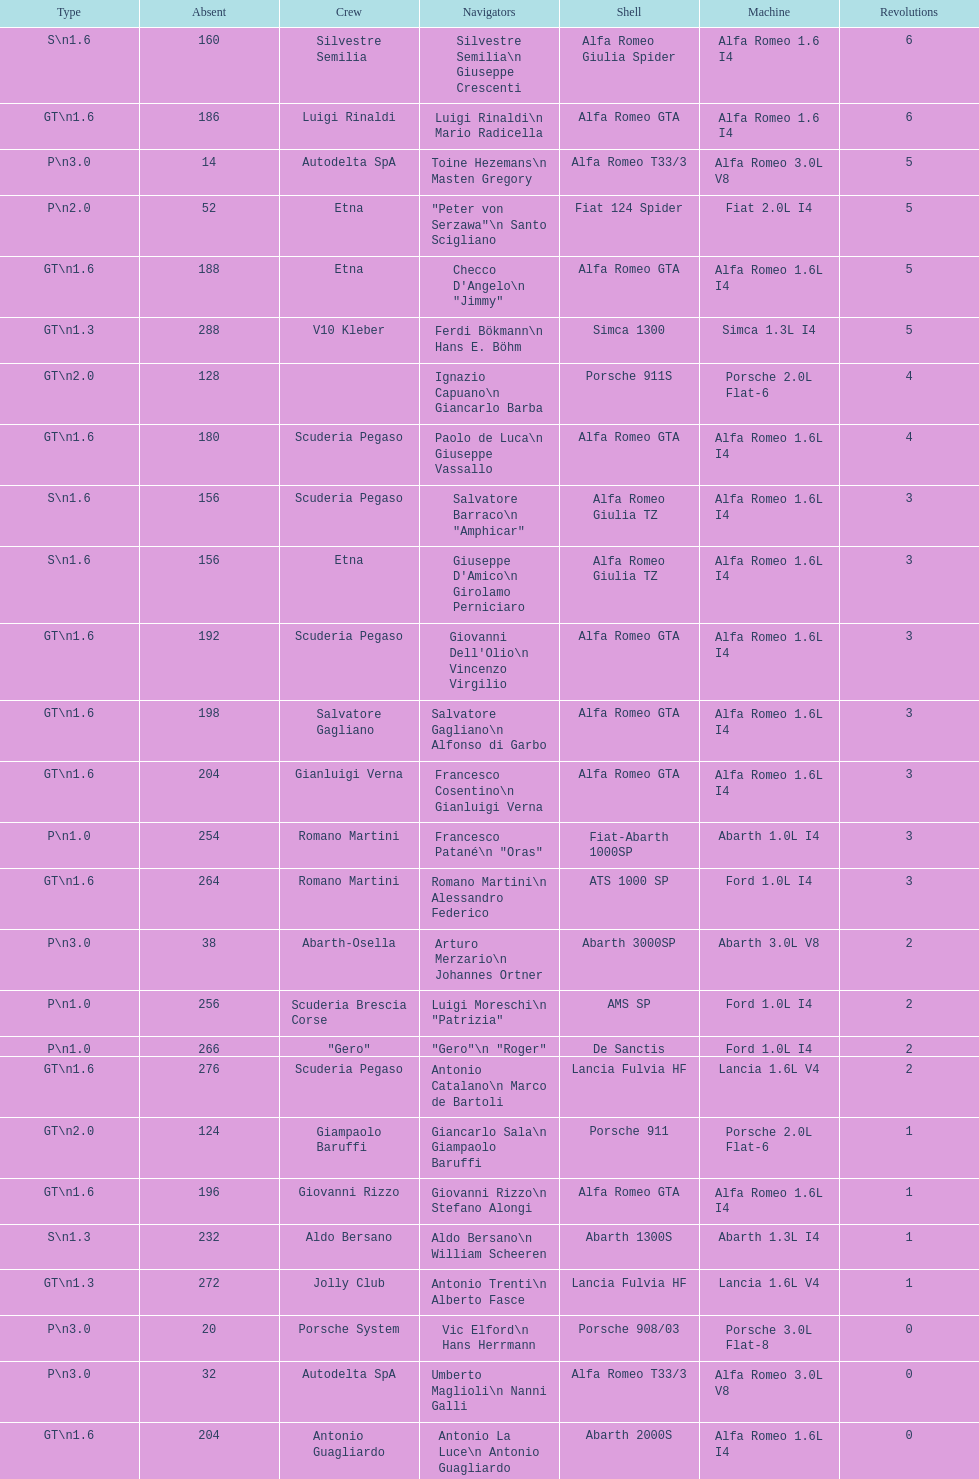How many teams were unable to finish the race following the completion of 2 laps? 4. Parse the table in full. {'header': ['Type', 'Absent', 'Crew', 'Navigators', 'Shell', 'Machine', 'Revolutions'], 'rows': [['S\\n1.6', '160', 'Silvestre Semilia', 'Silvestre Semilia\\n Giuseppe Crescenti', 'Alfa Romeo Giulia Spider', 'Alfa Romeo 1.6 I4', '6'], ['GT\\n1.6', '186', 'Luigi Rinaldi', 'Luigi Rinaldi\\n Mario Radicella', 'Alfa Romeo GTA', 'Alfa Romeo 1.6 I4', '6'], ['P\\n3.0', '14', 'Autodelta SpA', 'Toine Hezemans\\n Masten Gregory', 'Alfa Romeo T33/3', 'Alfa Romeo 3.0L V8', '5'], ['P\\n2.0', '52', 'Etna', '"Peter von Serzawa"\\n Santo Scigliano', 'Fiat 124 Spider', 'Fiat 2.0L I4', '5'], ['GT\\n1.6', '188', 'Etna', 'Checco D\'Angelo\\n "Jimmy"', 'Alfa Romeo GTA', 'Alfa Romeo 1.6L I4', '5'], ['GT\\n1.3', '288', 'V10 Kleber', 'Ferdi Bökmann\\n Hans E. Böhm', 'Simca 1300', 'Simca 1.3L I4', '5'], ['GT\\n2.0', '128', '', 'Ignazio Capuano\\n Giancarlo Barba', 'Porsche 911S', 'Porsche 2.0L Flat-6', '4'], ['GT\\n1.6', '180', 'Scuderia Pegaso', 'Paolo de Luca\\n Giuseppe Vassallo', 'Alfa Romeo GTA', 'Alfa Romeo 1.6L I4', '4'], ['S\\n1.6', '156', 'Scuderia Pegaso', 'Salvatore Barraco\\n "Amphicar"', 'Alfa Romeo Giulia TZ', 'Alfa Romeo 1.6L I4', '3'], ['S\\n1.6', '156', 'Etna', "Giuseppe D'Amico\\n Girolamo Perniciaro", 'Alfa Romeo Giulia TZ', 'Alfa Romeo 1.6L I4', '3'], ['GT\\n1.6', '192', 'Scuderia Pegaso', "Giovanni Dell'Olio\\n Vincenzo Virgilio", 'Alfa Romeo GTA', 'Alfa Romeo 1.6L I4', '3'], ['GT\\n1.6', '198', 'Salvatore Gagliano', 'Salvatore Gagliano\\n Alfonso di Garbo', 'Alfa Romeo GTA', 'Alfa Romeo 1.6L I4', '3'], ['GT\\n1.6', '204', 'Gianluigi Verna', 'Francesco Cosentino\\n Gianluigi Verna', 'Alfa Romeo GTA', 'Alfa Romeo 1.6L I4', '3'], ['P\\n1.0', '254', 'Romano Martini', 'Francesco Patané\\n "Oras"', 'Fiat-Abarth 1000SP', 'Abarth 1.0L I4', '3'], ['GT\\n1.6', '264', 'Romano Martini', 'Romano Martini\\n Alessandro Federico', 'ATS 1000 SP', 'Ford 1.0L I4', '3'], ['P\\n3.0', '38', 'Abarth-Osella', 'Arturo Merzario\\n Johannes Ortner', 'Abarth 3000SP', 'Abarth 3.0L V8', '2'], ['P\\n1.0', '256', 'Scuderia Brescia Corse', 'Luigi Moreschi\\n "Patrizia"', 'AMS SP', 'Ford 1.0L I4', '2'], ['P\\n1.0', '266', '"Gero"', '"Gero"\\n "Roger"', 'De Sanctis', 'Ford 1.0L I4', '2'], ['GT\\n1.6', '276', 'Scuderia Pegaso', 'Antonio Catalano\\n Marco de Bartoli', 'Lancia Fulvia HF', 'Lancia 1.6L V4', '2'], ['GT\\n2.0', '124', 'Giampaolo Baruffi', 'Giancarlo Sala\\n Giampaolo Baruffi', 'Porsche 911', 'Porsche 2.0L Flat-6', '1'], ['GT\\n1.6', '196', 'Giovanni Rizzo', 'Giovanni Rizzo\\n Stefano Alongi', 'Alfa Romeo GTA', 'Alfa Romeo 1.6L I4', '1'], ['S\\n1.3', '232', 'Aldo Bersano', 'Aldo Bersano\\n William Scheeren', 'Abarth 1300S', 'Abarth 1.3L I4', '1'], ['GT\\n1.3', '272', 'Jolly Club', 'Antonio Trenti\\n Alberto Fasce', 'Lancia Fulvia HF', 'Lancia 1.6L V4', '1'], ['P\\n3.0', '20', 'Porsche System', 'Vic Elford\\n Hans Herrmann', 'Porsche 908/03', 'Porsche 3.0L Flat-8', '0'], ['P\\n3.0', '32', 'Autodelta SpA', 'Umberto Maglioli\\n Nanni Galli', 'Alfa Romeo T33/3', 'Alfa Romeo 3.0L V8', '0'], ['GT\\n1.6', '204', 'Antonio Guagliardo', 'Antonio La Luce\\n Antonio Guagliardo', 'Abarth 2000S', 'Alfa Romeo 1.6L I4', '0'], ['P\\n1.3', '220', 'Jack Wheeler', 'Jack Wheeler\\n Martin Davidson', 'Jerboa SP', 'BMC 1.3L I4', '0'], ['S\\n1.3', '234', 'Settecolli', 'Enzo Buzzetti\\n Gianni Marini', 'Abarth 1300S', 'Abarth 1.6L I4', '0'], ['GT\\n1.3', '280', 'Scuderia Pegaso', 'Giuseppe Chiaramonte\\n Giuseppe Spatafora', 'Lancia Fulvia HF', 'Lancia 1.6L V4', '0']]} 